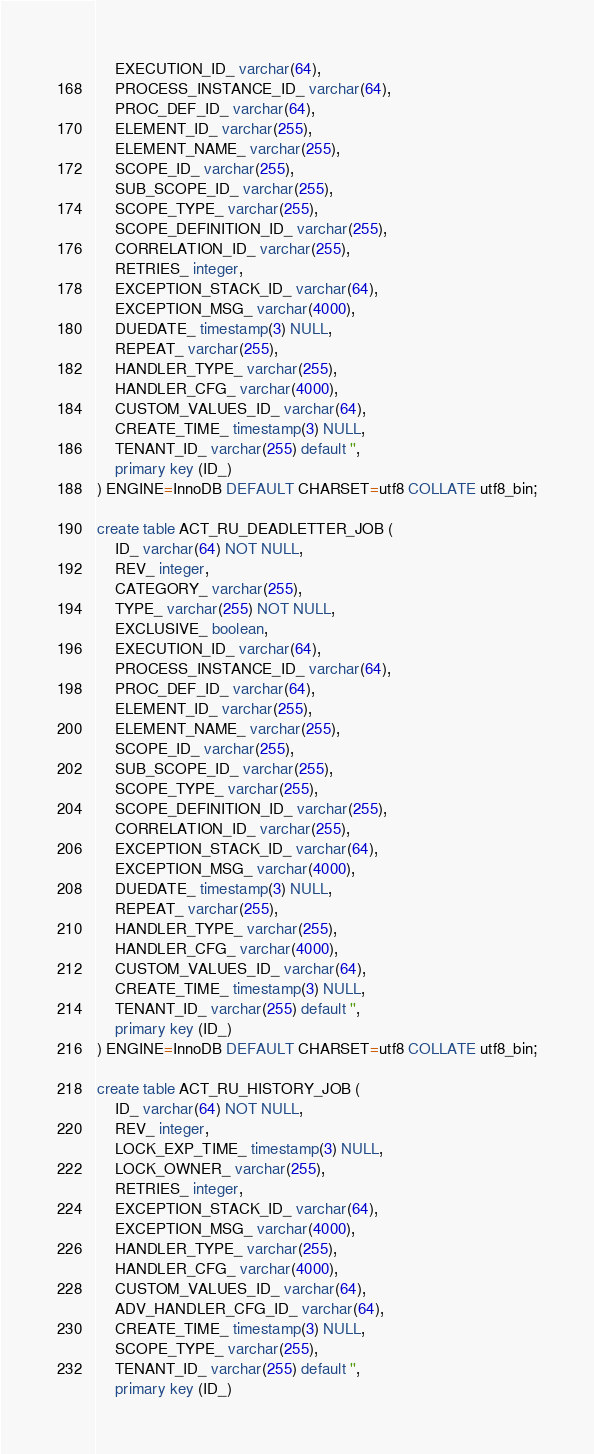Convert code to text. <code><loc_0><loc_0><loc_500><loc_500><_SQL_>    EXECUTION_ID_ varchar(64),
    PROCESS_INSTANCE_ID_ varchar(64),
    PROC_DEF_ID_ varchar(64),
    ELEMENT_ID_ varchar(255),
    ELEMENT_NAME_ varchar(255),
    SCOPE_ID_ varchar(255),
    SUB_SCOPE_ID_ varchar(255),
    SCOPE_TYPE_ varchar(255),
    SCOPE_DEFINITION_ID_ varchar(255),
    CORRELATION_ID_ varchar(255),
    RETRIES_ integer,
    EXCEPTION_STACK_ID_ varchar(64),
    EXCEPTION_MSG_ varchar(4000),
    DUEDATE_ timestamp(3) NULL,
    REPEAT_ varchar(255),
    HANDLER_TYPE_ varchar(255),
    HANDLER_CFG_ varchar(4000),
    CUSTOM_VALUES_ID_ varchar(64),
    CREATE_TIME_ timestamp(3) NULL,
    TENANT_ID_ varchar(255) default '',
    primary key (ID_)
) ENGINE=InnoDB DEFAULT CHARSET=utf8 COLLATE utf8_bin;

create table ACT_RU_DEADLETTER_JOB (
    ID_ varchar(64) NOT NULL,
    REV_ integer,
    CATEGORY_ varchar(255),
    TYPE_ varchar(255) NOT NULL,
    EXCLUSIVE_ boolean,
    EXECUTION_ID_ varchar(64),
    PROCESS_INSTANCE_ID_ varchar(64),
    PROC_DEF_ID_ varchar(64),
    ELEMENT_ID_ varchar(255),
    ELEMENT_NAME_ varchar(255),
    SCOPE_ID_ varchar(255),
    SUB_SCOPE_ID_ varchar(255),
    SCOPE_TYPE_ varchar(255),
    SCOPE_DEFINITION_ID_ varchar(255),
    CORRELATION_ID_ varchar(255),
    EXCEPTION_STACK_ID_ varchar(64),
    EXCEPTION_MSG_ varchar(4000),
    DUEDATE_ timestamp(3) NULL,
    REPEAT_ varchar(255),
    HANDLER_TYPE_ varchar(255),
    HANDLER_CFG_ varchar(4000),
    CUSTOM_VALUES_ID_ varchar(64),
    CREATE_TIME_ timestamp(3) NULL,
    TENANT_ID_ varchar(255) default '',
    primary key (ID_)
) ENGINE=InnoDB DEFAULT CHARSET=utf8 COLLATE utf8_bin;

create table ACT_RU_HISTORY_JOB (
    ID_ varchar(64) NOT NULL,
    REV_ integer,
    LOCK_EXP_TIME_ timestamp(3) NULL,
    LOCK_OWNER_ varchar(255),
    RETRIES_ integer,
    EXCEPTION_STACK_ID_ varchar(64),
    EXCEPTION_MSG_ varchar(4000),
    HANDLER_TYPE_ varchar(255),
    HANDLER_CFG_ varchar(4000),
    CUSTOM_VALUES_ID_ varchar(64),
    ADV_HANDLER_CFG_ID_ varchar(64),
    CREATE_TIME_ timestamp(3) NULL,
    SCOPE_TYPE_ varchar(255),
    TENANT_ID_ varchar(255) default '',
    primary key (ID_)</code> 